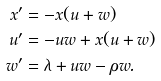<formula> <loc_0><loc_0><loc_500><loc_500>x ^ { \prime } & = - x ( u + w ) \\ u ^ { \prime } & = - u w + x ( u + w ) \\ w ^ { \prime } & = \lambda + u w - \rho w .</formula> 